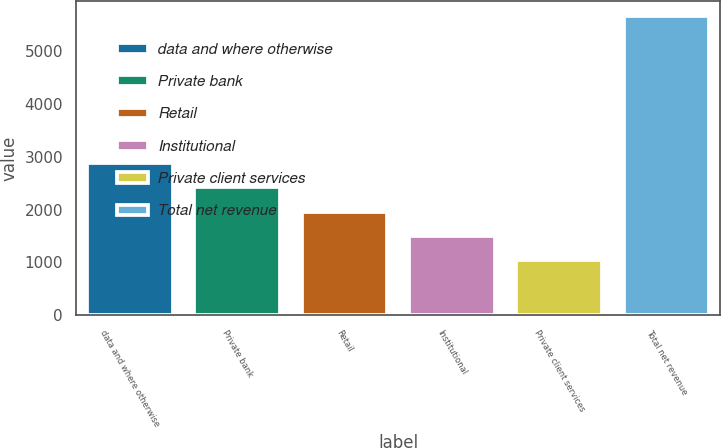<chart> <loc_0><loc_0><loc_500><loc_500><bar_chart><fcel>data and where otherwise<fcel>Private bank<fcel>Retail<fcel>Institutional<fcel>Private client services<fcel>Total net revenue<nl><fcel>2887.2<fcel>2424.4<fcel>1961.6<fcel>1498.8<fcel>1036<fcel>5664<nl></chart> 